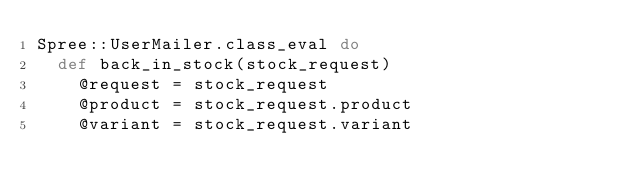Convert code to text. <code><loc_0><loc_0><loc_500><loc_500><_Ruby_>Spree::UserMailer.class_eval do
  def back_in_stock(stock_request)
    @request = stock_request
    @product = stock_request.product
    @variant = stock_request.variant
</code> 